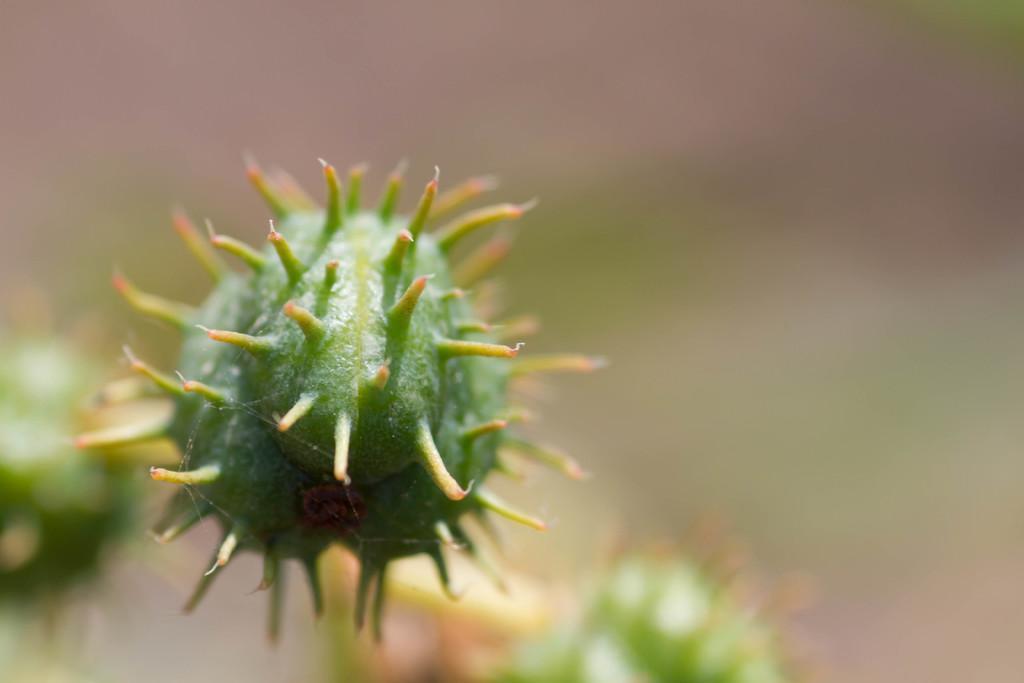Could you give a brief overview of what you see in this image? In the center of the image we can see flower. 